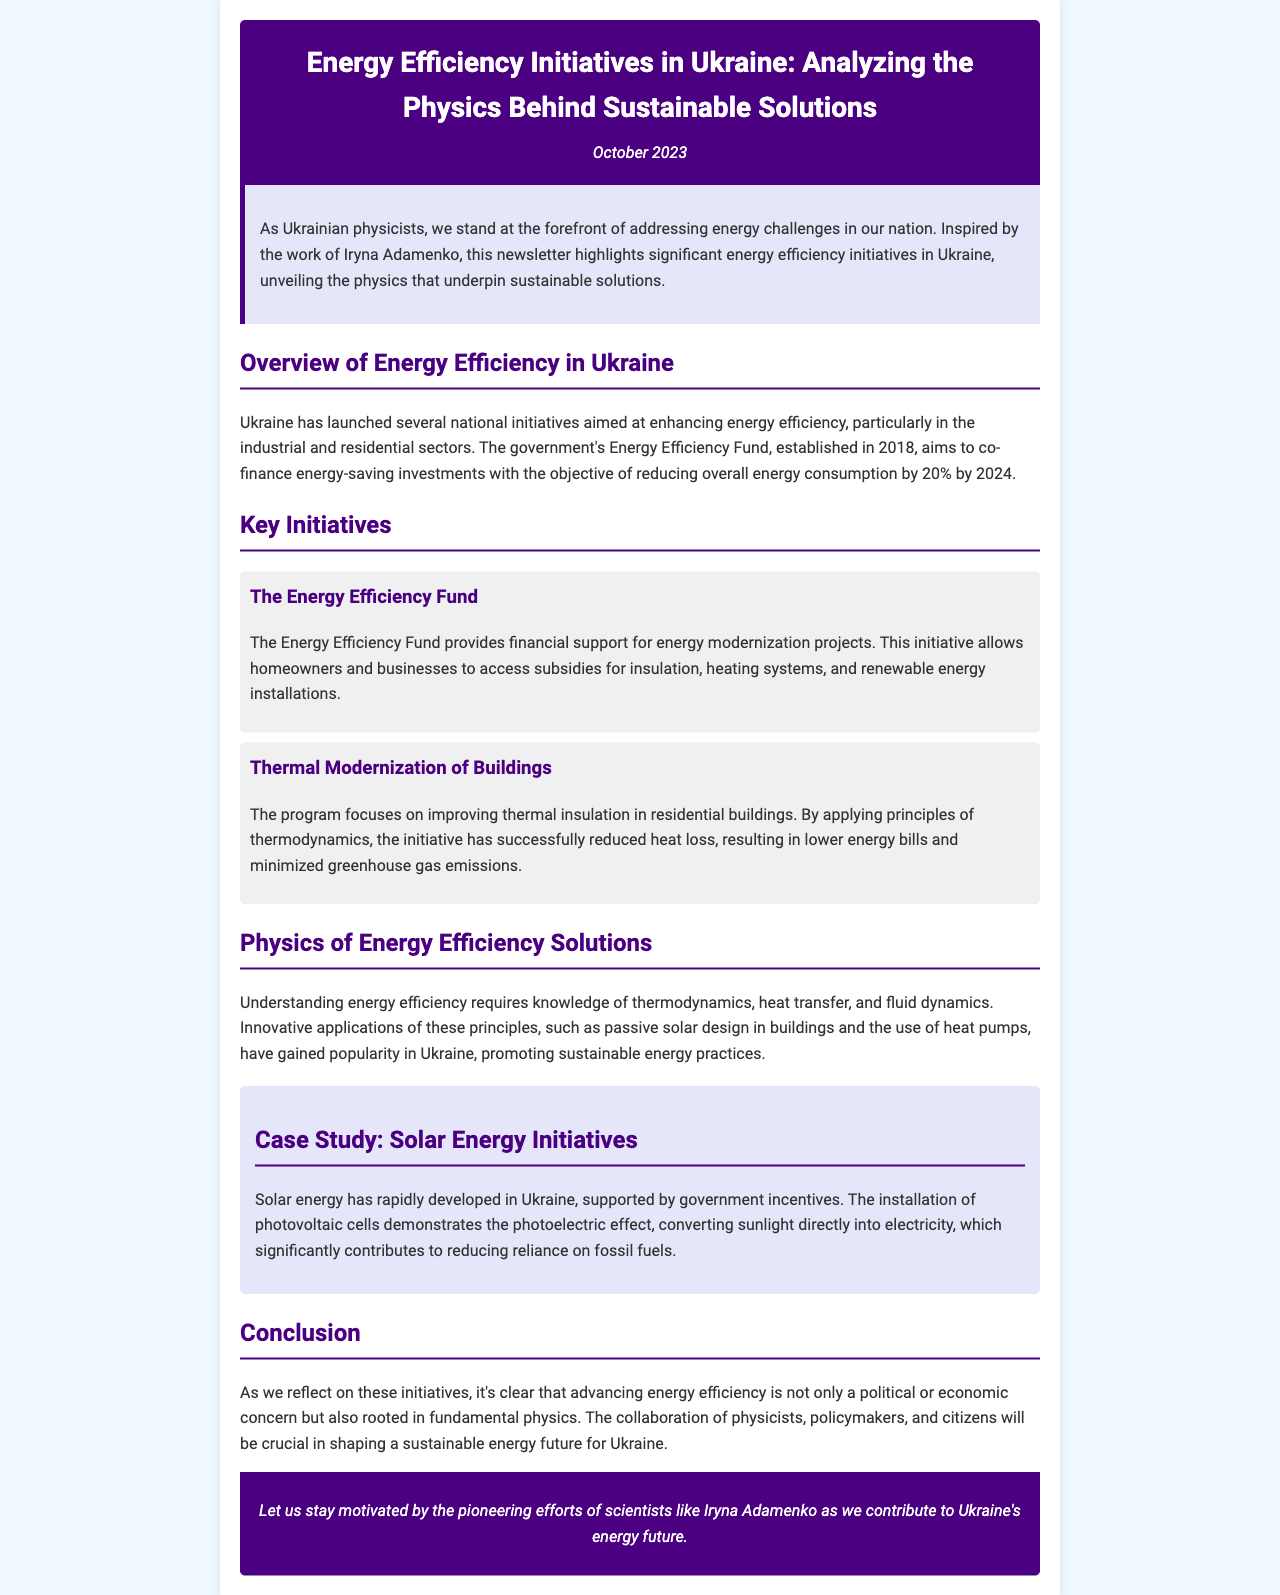What is the title of the newsletter? The title is prominently displayed in the header section of the document.
Answer: Energy Efficiency Initiatives in Ukraine: Analyzing the Physics Behind Sustainable Solutions When was the newsletter published? The date is indicated right below the title of the newsletter.
Answer: October 2023 What is the main goal of the Energy Efficiency Fund? The goal is mentioned in the overview section of the document.
Answer: Reducing overall energy consumption by 20% by 2024 What type of projects does the Energy Efficiency Fund support? The supported projects are specified in the description of the initiative.
Answer: Energy modernization projects What scientific principles are emphasized in the physics of energy efficiency solutions? The section discusses the principles that underlie energy efficiency.
Answer: Thermodynamics, heat transfer, and fluid dynamics What case study is highlighted in the newsletter? The case study section details a specific energy initiative.
Answer: Solar Energy Initiatives Which initiative focuses on thermal insulation? The initiative dealing with insulation is described in the key initiatives section.
Answer: Thermal Modernization of Buildings Who inspired the newsletter's focus on energy efficiency? The introduction mentions a specific individual whose work serves as an inspiration.
Answer: Iryna Adamenko 